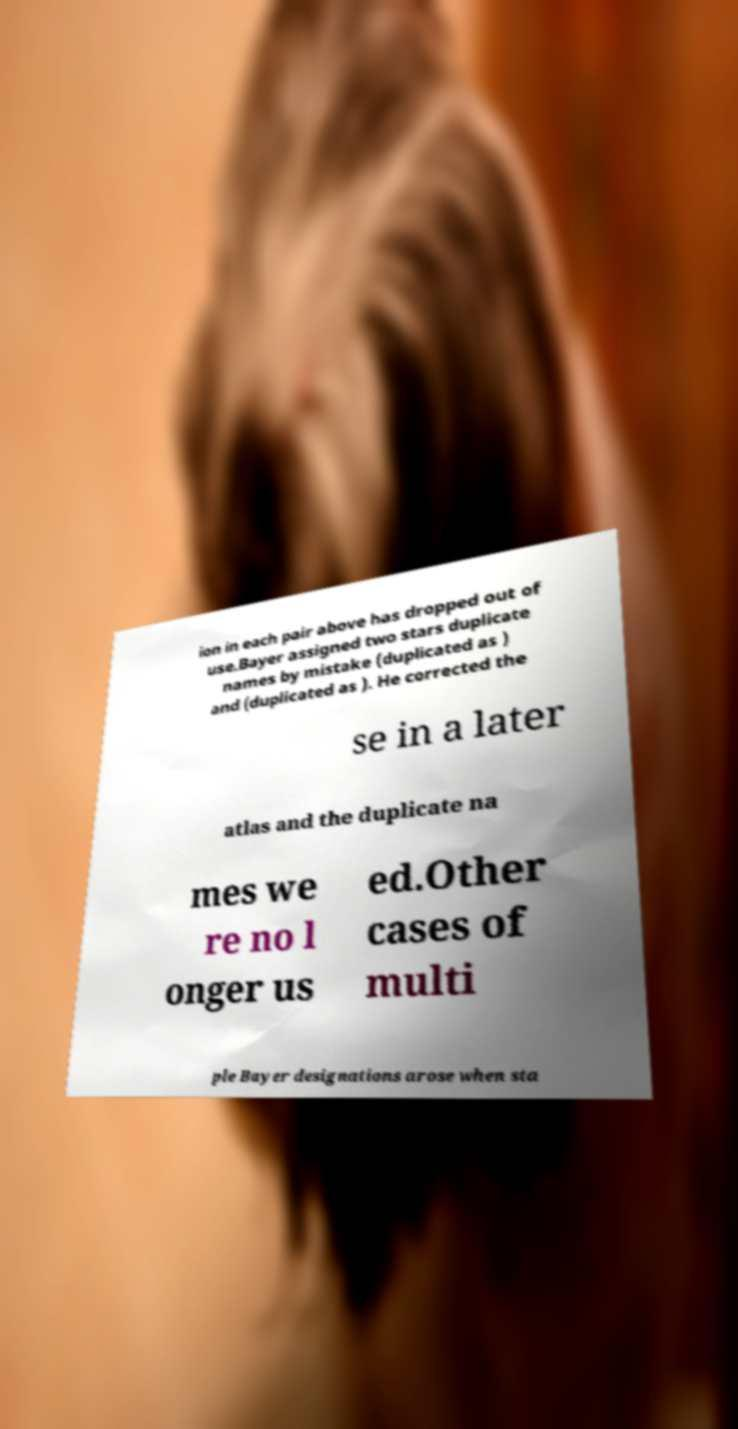What messages or text are displayed in this image? I need them in a readable, typed format. ion in each pair above has dropped out of use.Bayer assigned two stars duplicate names by mistake (duplicated as ) and (duplicated as ). He corrected the se in a later atlas and the duplicate na mes we re no l onger us ed.Other cases of multi ple Bayer designations arose when sta 